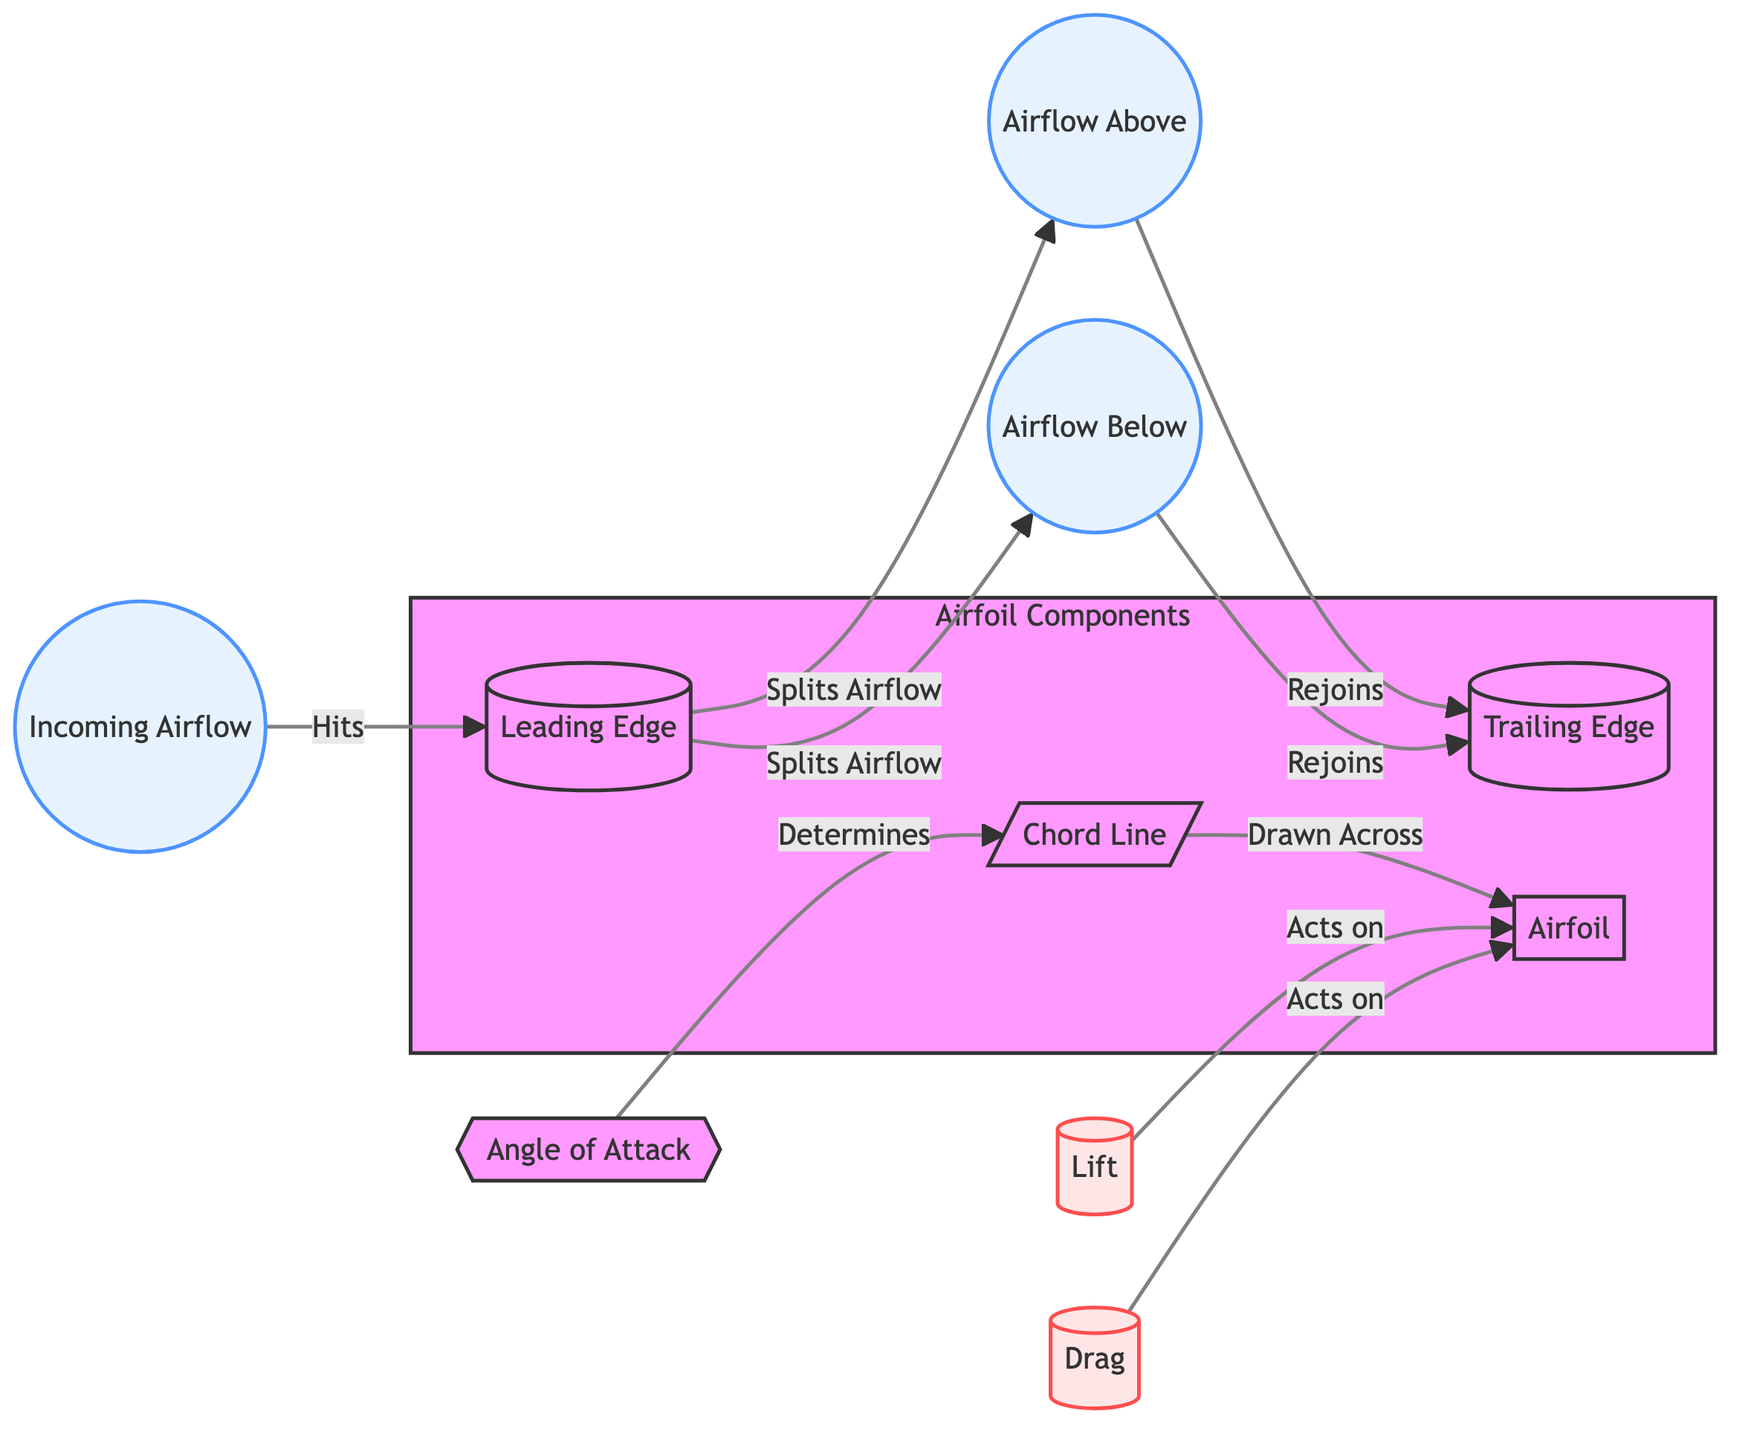What is the term for the airflow that hits the leading edge? The airflow that encounters the leading edge is identified as "Incoming Airflow" in the diagram. It is represented as the first node in the flowchart, showing the starting point of the airflow before it interacts with the airfoil.
Answer: Incoming Airflow How many edges are there connected to the leading edge? The leading edge connects to two edges: one leading to the airflow above and another to the airflow below. This bifurcation represents how the airflow is divided as it reaches the airfoil.
Answer: 2 What does the angle of attack determine? The angle of attack determines the placement of the chord line in the diagram. This relationship indicates how the airfoil's position affects its aerodynamics. The chord line is a straight line drawn across the airfoil from leading edge to trailing edge.
Answer: Chord Line What acts on the airfoil according to the diagram? Two forces are identified that act on the airfoil: Lift and Drag. These forces are critical in understanding how the airfoil performs during flight, influencing its ability to generate lift and its resistance to motion.
Answer: Lift and Drag Which airflow segment rejoins at the trailing edge? Both segments of airflow mentioned in the diagram—airflow above and airflow below—rejoin at the trailing edge after having split off at the leading edge. This illustrates how the airflow patterns integrate and interact at the back of the airfoil.
Answer: Airflow Above and Airflow Below How does airflow split at the leading edge? At the leading edge, the airflow splits into two paths: airflow above and airflow below. This bifurcation is essential for producing the aerodynamic forces necessary for lift.
Answer: Splits Into Two Paths What occurs at the trailing edge? At the trailing edge, the airflow from above and below rejoins. This interaction is critical for determining the overall aerodynamic performance of the airfoil, influencing lift and drag forces as they exit the airfoil.
Answer: Airflow Rejoins 